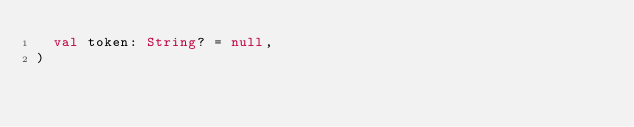Convert code to text. <code><loc_0><loc_0><loc_500><loc_500><_Kotlin_>  val token: String? = null,
)
</code> 